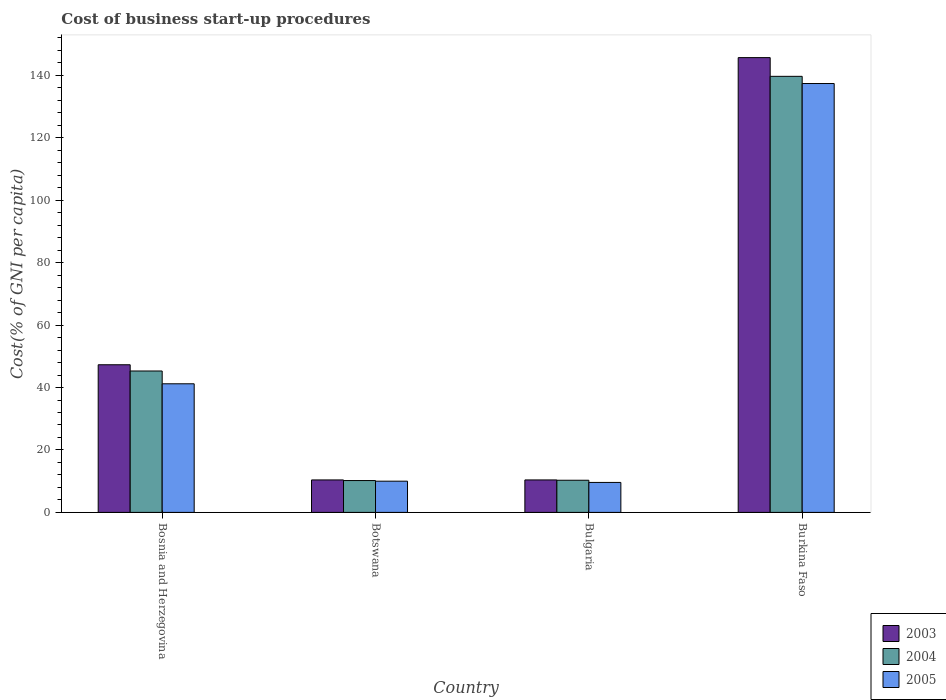Are the number of bars per tick equal to the number of legend labels?
Your response must be concise. Yes. How many bars are there on the 3rd tick from the left?
Your answer should be very brief. 3. How many bars are there on the 3rd tick from the right?
Offer a terse response. 3. What is the label of the 2nd group of bars from the left?
Give a very brief answer. Botswana. In how many cases, is the number of bars for a given country not equal to the number of legend labels?
Offer a terse response. 0. What is the cost of business start-up procedures in 2003 in Burkina Faso?
Your response must be concise. 145.7. Across all countries, what is the maximum cost of business start-up procedures in 2004?
Provide a short and direct response. 139.7. In which country was the cost of business start-up procedures in 2004 maximum?
Offer a very short reply. Burkina Faso. In which country was the cost of business start-up procedures in 2004 minimum?
Offer a terse response. Botswana. What is the total cost of business start-up procedures in 2004 in the graph?
Offer a very short reply. 205.5. What is the difference between the cost of business start-up procedures in 2005 in Bosnia and Herzegovina and that in Burkina Faso?
Make the answer very short. -96.2. What is the difference between the cost of business start-up procedures in 2004 in Bulgaria and the cost of business start-up procedures in 2003 in Burkina Faso?
Offer a terse response. -135.4. What is the average cost of business start-up procedures in 2003 per country?
Offer a very short reply. 53.45. What is the difference between the cost of business start-up procedures of/in 2004 and cost of business start-up procedures of/in 2005 in Burkina Faso?
Offer a very short reply. 2.3. What is the ratio of the cost of business start-up procedures in 2004 in Botswana to that in Burkina Faso?
Make the answer very short. 0.07. Is the cost of business start-up procedures in 2003 in Botswana less than that in Bulgaria?
Your answer should be very brief. No. Is the difference between the cost of business start-up procedures in 2004 in Bosnia and Herzegovina and Botswana greater than the difference between the cost of business start-up procedures in 2005 in Bosnia and Herzegovina and Botswana?
Your answer should be compact. Yes. What is the difference between the highest and the second highest cost of business start-up procedures in 2005?
Keep it short and to the point. 127.4. What is the difference between the highest and the lowest cost of business start-up procedures in 2003?
Offer a terse response. 135.3. In how many countries, is the cost of business start-up procedures in 2005 greater than the average cost of business start-up procedures in 2005 taken over all countries?
Your response must be concise. 1. Is the sum of the cost of business start-up procedures in 2005 in Botswana and Burkina Faso greater than the maximum cost of business start-up procedures in 2003 across all countries?
Give a very brief answer. Yes. How many bars are there?
Make the answer very short. 12. Are all the bars in the graph horizontal?
Your response must be concise. No. How many countries are there in the graph?
Give a very brief answer. 4. What is the difference between two consecutive major ticks on the Y-axis?
Your answer should be compact. 20. Does the graph contain any zero values?
Your response must be concise. No. Does the graph contain grids?
Keep it short and to the point. No. Where does the legend appear in the graph?
Offer a very short reply. Bottom right. How are the legend labels stacked?
Keep it short and to the point. Vertical. What is the title of the graph?
Your answer should be very brief. Cost of business start-up procedures. What is the label or title of the X-axis?
Offer a very short reply. Country. What is the label or title of the Y-axis?
Offer a terse response. Cost(% of GNI per capita). What is the Cost(% of GNI per capita) of 2003 in Bosnia and Herzegovina?
Make the answer very short. 47.3. What is the Cost(% of GNI per capita) in 2004 in Bosnia and Herzegovina?
Your answer should be very brief. 45.3. What is the Cost(% of GNI per capita) in 2005 in Bosnia and Herzegovina?
Provide a succinct answer. 41.2. What is the Cost(% of GNI per capita) in 2003 in Botswana?
Your answer should be compact. 10.4. What is the Cost(% of GNI per capita) in 2004 in Botswana?
Offer a very short reply. 10.2. What is the Cost(% of GNI per capita) in 2005 in Botswana?
Provide a short and direct response. 10. What is the Cost(% of GNI per capita) of 2003 in Bulgaria?
Your response must be concise. 10.4. What is the Cost(% of GNI per capita) in 2003 in Burkina Faso?
Your response must be concise. 145.7. What is the Cost(% of GNI per capita) of 2004 in Burkina Faso?
Make the answer very short. 139.7. What is the Cost(% of GNI per capita) in 2005 in Burkina Faso?
Offer a very short reply. 137.4. Across all countries, what is the maximum Cost(% of GNI per capita) in 2003?
Give a very brief answer. 145.7. Across all countries, what is the maximum Cost(% of GNI per capita) of 2004?
Your answer should be compact. 139.7. Across all countries, what is the maximum Cost(% of GNI per capita) of 2005?
Your response must be concise. 137.4. Across all countries, what is the minimum Cost(% of GNI per capita) in 2003?
Ensure brevity in your answer.  10.4. Across all countries, what is the minimum Cost(% of GNI per capita) in 2004?
Offer a terse response. 10.2. Across all countries, what is the minimum Cost(% of GNI per capita) of 2005?
Offer a very short reply. 9.6. What is the total Cost(% of GNI per capita) in 2003 in the graph?
Provide a short and direct response. 213.8. What is the total Cost(% of GNI per capita) of 2004 in the graph?
Provide a succinct answer. 205.5. What is the total Cost(% of GNI per capita) of 2005 in the graph?
Provide a succinct answer. 198.2. What is the difference between the Cost(% of GNI per capita) in 2003 in Bosnia and Herzegovina and that in Botswana?
Keep it short and to the point. 36.9. What is the difference between the Cost(% of GNI per capita) of 2004 in Bosnia and Herzegovina and that in Botswana?
Keep it short and to the point. 35.1. What is the difference between the Cost(% of GNI per capita) in 2005 in Bosnia and Herzegovina and that in Botswana?
Ensure brevity in your answer.  31.2. What is the difference between the Cost(% of GNI per capita) in 2003 in Bosnia and Herzegovina and that in Bulgaria?
Provide a short and direct response. 36.9. What is the difference between the Cost(% of GNI per capita) in 2004 in Bosnia and Herzegovina and that in Bulgaria?
Your answer should be very brief. 35. What is the difference between the Cost(% of GNI per capita) of 2005 in Bosnia and Herzegovina and that in Bulgaria?
Offer a terse response. 31.6. What is the difference between the Cost(% of GNI per capita) in 2003 in Bosnia and Herzegovina and that in Burkina Faso?
Offer a terse response. -98.4. What is the difference between the Cost(% of GNI per capita) of 2004 in Bosnia and Herzegovina and that in Burkina Faso?
Ensure brevity in your answer.  -94.4. What is the difference between the Cost(% of GNI per capita) of 2005 in Bosnia and Herzegovina and that in Burkina Faso?
Provide a short and direct response. -96.2. What is the difference between the Cost(% of GNI per capita) of 2005 in Botswana and that in Bulgaria?
Ensure brevity in your answer.  0.4. What is the difference between the Cost(% of GNI per capita) in 2003 in Botswana and that in Burkina Faso?
Your response must be concise. -135.3. What is the difference between the Cost(% of GNI per capita) in 2004 in Botswana and that in Burkina Faso?
Your answer should be very brief. -129.5. What is the difference between the Cost(% of GNI per capita) of 2005 in Botswana and that in Burkina Faso?
Provide a succinct answer. -127.4. What is the difference between the Cost(% of GNI per capita) of 2003 in Bulgaria and that in Burkina Faso?
Offer a terse response. -135.3. What is the difference between the Cost(% of GNI per capita) of 2004 in Bulgaria and that in Burkina Faso?
Your answer should be compact. -129.4. What is the difference between the Cost(% of GNI per capita) of 2005 in Bulgaria and that in Burkina Faso?
Give a very brief answer. -127.8. What is the difference between the Cost(% of GNI per capita) in 2003 in Bosnia and Herzegovina and the Cost(% of GNI per capita) in 2004 in Botswana?
Your answer should be very brief. 37.1. What is the difference between the Cost(% of GNI per capita) in 2003 in Bosnia and Herzegovina and the Cost(% of GNI per capita) in 2005 in Botswana?
Your response must be concise. 37.3. What is the difference between the Cost(% of GNI per capita) of 2004 in Bosnia and Herzegovina and the Cost(% of GNI per capita) of 2005 in Botswana?
Provide a succinct answer. 35.3. What is the difference between the Cost(% of GNI per capita) in 2003 in Bosnia and Herzegovina and the Cost(% of GNI per capita) in 2005 in Bulgaria?
Your response must be concise. 37.7. What is the difference between the Cost(% of GNI per capita) of 2004 in Bosnia and Herzegovina and the Cost(% of GNI per capita) of 2005 in Bulgaria?
Your response must be concise. 35.7. What is the difference between the Cost(% of GNI per capita) in 2003 in Bosnia and Herzegovina and the Cost(% of GNI per capita) in 2004 in Burkina Faso?
Provide a short and direct response. -92.4. What is the difference between the Cost(% of GNI per capita) of 2003 in Bosnia and Herzegovina and the Cost(% of GNI per capita) of 2005 in Burkina Faso?
Offer a very short reply. -90.1. What is the difference between the Cost(% of GNI per capita) in 2004 in Bosnia and Herzegovina and the Cost(% of GNI per capita) in 2005 in Burkina Faso?
Provide a short and direct response. -92.1. What is the difference between the Cost(% of GNI per capita) of 2004 in Botswana and the Cost(% of GNI per capita) of 2005 in Bulgaria?
Provide a succinct answer. 0.6. What is the difference between the Cost(% of GNI per capita) of 2003 in Botswana and the Cost(% of GNI per capita) of 2004 in Burkina Faso?
Provide a short and direct response. -129.3. What is the difference between the Cost(% of GNI per capita) of 2003 in Botswana and the Cost(% of GNI per capita) of 2005 in Burkina Faso?
Keep it short and to the point. -127. What is the difference between the Cost(% of GNI per capita) of 2004 in Botswana and the Cost(% of GNI per capita) of 2005 in Burkina Faso?
Provide a short and direct response. -127.2. What is the difference between the Cost(% of GNI per capita) of 2003 in Bulgaria and the Cost(% of GNI per capita) of 2004 in Burkina Faso?
Provide a short and direct response. -129.3. What is the difference between the Cost(% of GNI per capita) in 2003 in Bulgaria and the Cost(% of GNI per capita) in 2005 in Burkina Faso?
Give a very brief answer. -127. What is the difference between the Cost(% of GNI per capita) in 2004 in Bulgaria and the Cost(% of GNI per capita) in 2005 in Burkina Faso?
Give a very brief answer. -127.1. What is the average Cost(% of GNI per capita) of 2003 per country?
Ensure brevity in your answer.  53.45. What is the average Cost(% of GNI per capita) in 2004 per country?
Your response must be concise. 51.38. What is the average Cost(% of GNI per capita) in 2005 per country?
Your answer should be compact. 49.55. What is the difference between the Cost(% of GNI per capita) in 2003 and Cost(% of GNI per capita) in 2004 in Bosnia and Herzegovina?
Provide a short and direct response. 2. What is the difference between the Cost(% of GNI per capita) of 2003 and Cost(% of GNI per capita) of 2005 in Bosnia and Herzegovina?
Your answer should be very brief. 6.1. What is the difference between the Cost(% of GNI per capita) in 2004 and Cost(% of GNI per capita) in 2005 in Bosnia and Herzegovina?
Give a very brief answer. 4.1. What is the difference between the Cost(% of GNI per capita) of 2003 and Cost(% of GNI per capita) of 2005 in Botswana?
Keep it short and to the point. 0.4. What is the difference between the Cost(% of GNI per capita) in 2004 and Cost(% of GNI per capita) in 2005 in Botswana?
Offer a very short reply. 0.2. What is the difference between the Cost(% of GNI per capita) of 2003 and Cost(% of GNI per capita) of 2004 in Bulgaria?
Offer a very short reply. 0.1. What is the difference between the Cost(% of GNI per capita) of 2004 and Cost(% of GNI per capita) of 2005 in Bulgaria?
Your answer should be very brief. 0.7. What is the difference between the Cost(% of GNI per capita) of 2003 and Cost(% of GNI per capita) of 2004 in Burkina Faso?
Your response must be concise. 6. What is the difference between the Cost(% of GNI per capita) of 2003 and Cost(% of GNI per capita) of 2005 in Burkina Faso?
Ensure brevity in your answer.  8.3. What is the ratio of the Cost(% of GNI per capita) of 2003 in Bosnia and Herzegovina to that in Botswana?
Ensure brevity in your answer.  4.55. What is the ratio of the Cost(% of GNI per capita) of 2004 in Bosnia and Herzegovina to that in Botswana?
Give a very brief answer. 4.44. What is the ratio of the Cost(% of GNI per capita) of 2005 in Bosnia and Herzegovina to that in Botswana?
Your answer should be compact. 4.12. What is the ratio of the Cost(% of GNI per capita) of 2003 in Bosnia and Herzegovina to that in Bulgaria?
Your answer should be very brief. 4.55. What is the ratio of the Cost(% of GNI per capita) in 2004 in Bosnia and Herzegovina to that in Bulgaria?
Make the answer very short. 4.4. What is the ratio of the Cost(% of GNI per capita) of 2005 in Bosnia and Herzegovina to that in Bulgaria?
Offer a terse response. 4.29. What is the ratio of the Cost(% of GNI per capita) of 2003 in Bosnia and Herzegovina to that in Burkina Faso?
Your answer should be very brief. 0.32. What is the ratio of the Cost(% of GNI per capita) in 2004 in Bosnia and Herzegovina to that in Burkina Faso?
Provide a short and direct response. 0.32. What is the ratio of the Cost(% of GNI per capita) of 2005 in Bosnia and Herzegovina to that in Burkina Faso?
Your answer should be very brief. 0.3. What is the ratio of the Cost(% of GNI per capita) of 2004 in Botswana to that in Bulgaria?
Provide a short and direct response. 0.99. What is the ratio of the Cost(% of GNI per capita) in 2005 in Botswana to that in Bulgaria?
Your answer should be compact. 1.04. What is the ratio of the Cost(% of GNI per capita) in 2003 in Botswana to that in Burkina Faso?
Your answer should be compact. 0.07. What is the ratio of the Cost(% of GNI per capita) in 2004 in Botswana to that in Burkina Faso?
Offer a terse response. 0.07. What is the ratio of the Cost(% of GNI per capita) of 2005 in Botswana to that in Burkina Faso?
Offer a terse response. 0.07. What is the ratio of the Cost(% of GNI per capita) in 2003 in Bulgaria to that in Burkina Faso?
Your answer should be compact. 0.07. What is the ratio of the Cost(% of GNI per capita) in 2004 in Bulgaria to that in Burkina Faso?
Your answer should be compact. 0.07. What is the ratio of the Cost(% of GNI per capita) of 2005 in Bulgaria to that in Burkina Faso?
Your answer should be compact. 0.07. What is the difference between the highest and the second highest Cost(% of GNI per capita) of 2003?
Ensure brevity in your answer.  98.4. What is the difference between the highest and the second highest Cost(% of GNI per capita) in 2004?
Keep it short and to the point. 94.4. What is the difference between the highest and the second highest Cost(% of GNI per capita) in 2005?
Make the answer very short. 96.2. What is the difference between the highest and the lowest Cost(% of GNI per capita) of 2003?
Provide a short and direct response. 135.3. What is the difference between the highest and the lowest Cost(% of GNI per capita) in 2004?
Offer a very short reply. 129.5. What is the difference between the highest and the lowest Cost(% of GNI per capita) of 2005?
Ensure brevity in your answer.  127.8. 